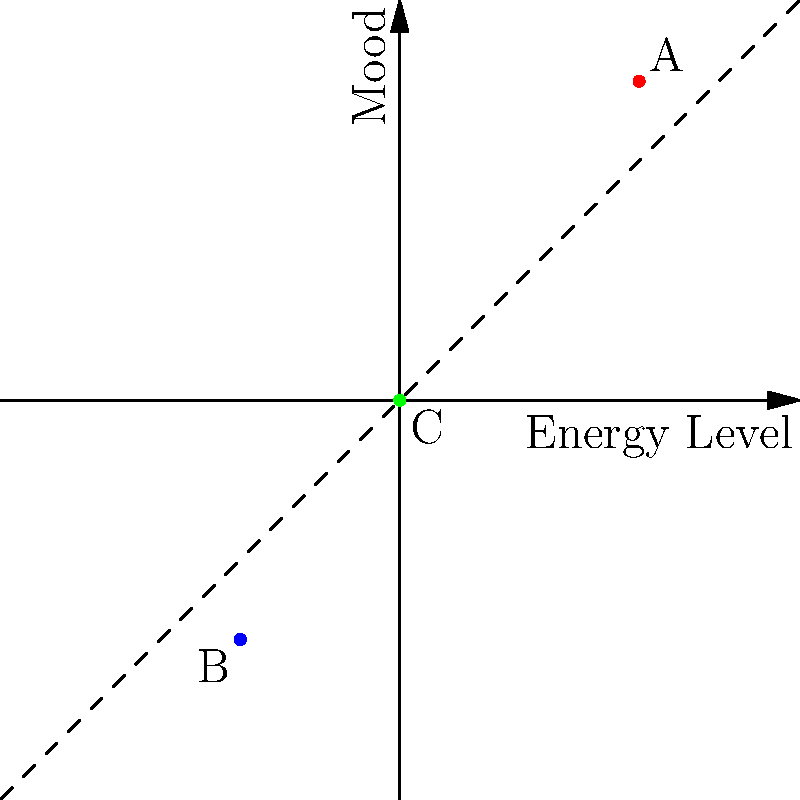On the mood chart above, points represent different emotional states. The x-axis represents energy level (from low to high), and the y-axis represents mood (from negative to positive). Which point best represents a state of depression, and why? To answer this question, we need to analyze the coordinates of each point and understand what they represent in terms of mood and energy level:

1. Point A (3, 4): This point is in the first quadrant, indicating both high energy (x = 3) and positive mood (y = 4).

2. Point B (-2, -3): This point is in the third quadrant, showing both low energy (x = -2) and negative mood (y = -3).

3. Point C (0, 0): This point is at the origin, representing neutral energy and mood.

Depression is typically characterized by both low energy (fatigue, lack of motivation) and negative mood (sadness, hopelessness). Therefore, we are looking for a point in the third quadrant of the coordinate system.

Among the given points, Point B (-2, -3) best represents a state of depression because:
- Its x-coordinate (-2) indicates low energy
- Its y-coordinate (-3) indicates negative mood

Both of these characteristics align with the common symptoms of depression.
Answer: Point B (-2, -3) 